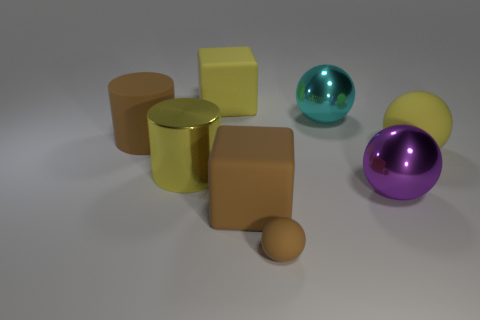Can you describe the texture and material of the object that is reflecting the light? The object that is reflecting light in the image is a sphere with a smooth surface, suggesting it's made of a reflective, glossy material like polished metal or glass. Is there an object that looks soft or might be made of a different material than the others? There isn't any object in the image that clearly looks soft or as though it's made of a soft material. All objects in the image have hard, smooth surfaces indicative of materials like metal, glass, or plastic. 